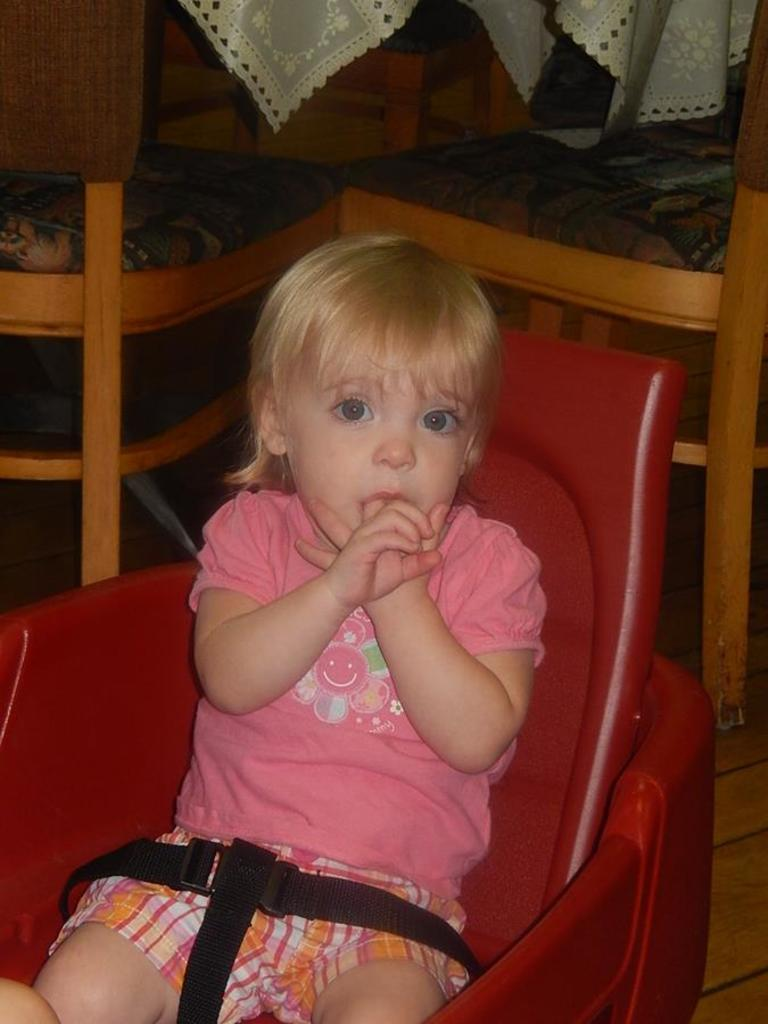What is the main subject of the image? There is a baby in the center of the image. What is the baby sitting on? The baby is sitting on a chair. Are there any other chairs visible in the image? Yes, there are two more chairs in the background of the image. What type of material can be seen in the background? There is cloth visible in the background of the image. What type of trick is the baby performing with the stocking and liquid in the image? There is no trick, stocking, or liquid present in the image. The image only features a baby sitting on a chair with two more chairs and cloth visible in the background. 